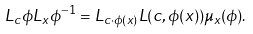<formula> <loc_0><loc_0><loc_500><loc_500>L _ { c } \phi L _ { x } \phi ^ { - 1 } = L _ { c \cdot \phi ( x ) } L ( c , \phi ( x ) ) \mu _ { x } ( \phi ) .</formula> 